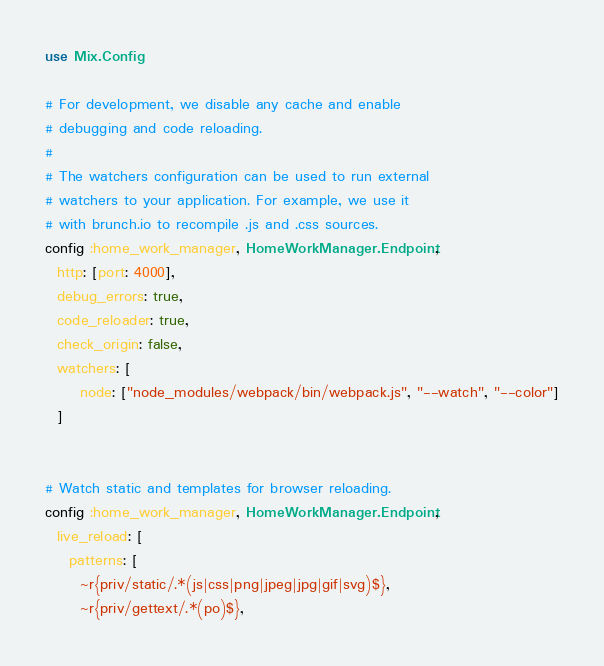<code> <loc_0><loc_0><loc_500><loc_500><_Elixir_>use Mix.Config

# For development, we disable any cache and enable
# debugging and code reloading.
#
# The watchers configuration can be used to run external
# watchers to your application. For example, we use it
# with brunch.io to recompile .js and .css sources.
config :home_work_manager, HomeWorkManager.Endpoint,
  http: [port: 4000],
  debug_errors: true,
  code_reloader: true,
  check_origin: false,
  watchers: [
      node: ["node_modules/webpack/bin/webpack.js", "--watch", "--color"]
  ]


# Watch static and templates for browser reloading.
config :home_work_manager, HomeWorkManager.Endpoint,
  live_reload: [
    patterns: [
      ~r{priv/static/.*(js|css|png|jpeg|jpg|gif|svg)$},
      ~r{priv/gettext/.*(po)$},</code> 